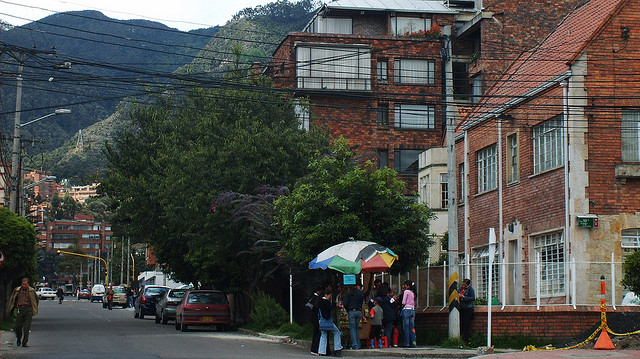How many grey bears are in the picture? There are no grey bears visible in the picture, as it depicts a city street with buildings, cars, and people, but no wildlife. 